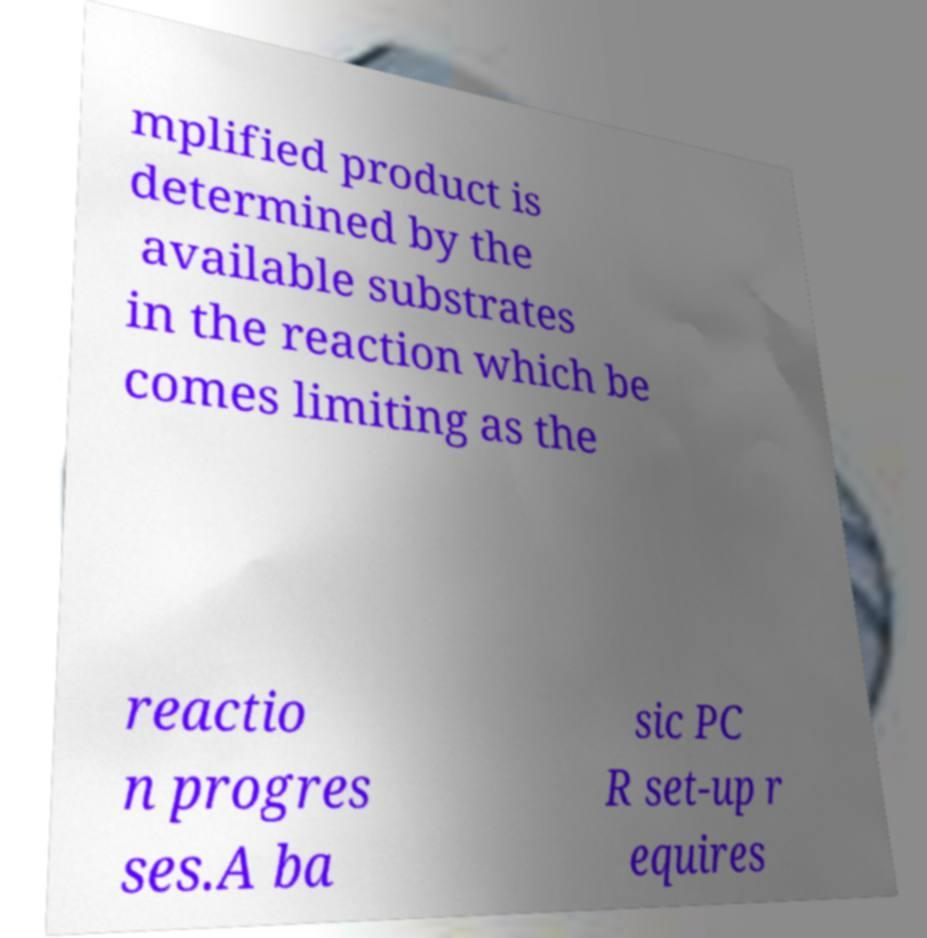There's text embedded in this image that I need extracted. Can you transcribe it verbatim? mplified product is determined by the available substrates in the reaction which be comes limiting as the reactio n progres ses.A ba sic PC R set-up r equires 